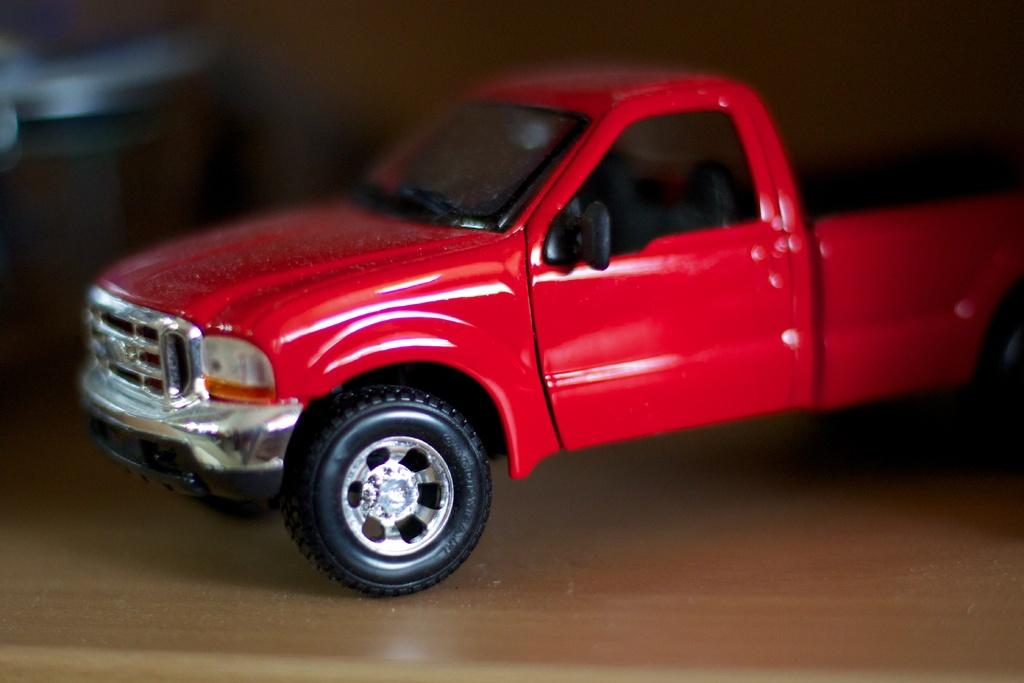What type of toy is in the image? There is a red toy car in the image. What is the toy car placed on? The toy car is placed on a wooden surface. Can you describe the surroundings of the image? The surroundings of the image are blurred. Are there any plantations visible in the image? There are no plantations present in the image. Is the toy car positioned on a slope in the image? The toy car is not positioned on a slope in the image; it is placed on a wooden surface. 